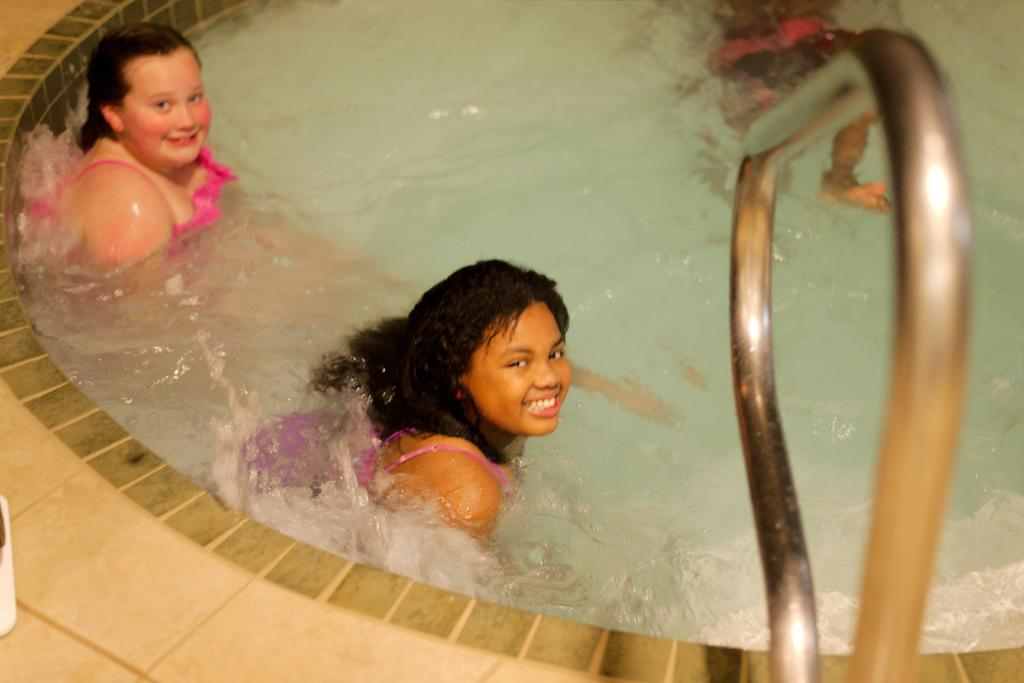How many people are in the swimming pool in the image? There are two girls in the swimming pool in the image. What is the facial expression of the girls in the image? The girls are smiling in the image. What can be seen on the right side of the image? There is railing on the right side of the image. What song are the girls singing in the image? There is no indication in the image that the girls are singing a song, so it cannot be determined from the picture. 